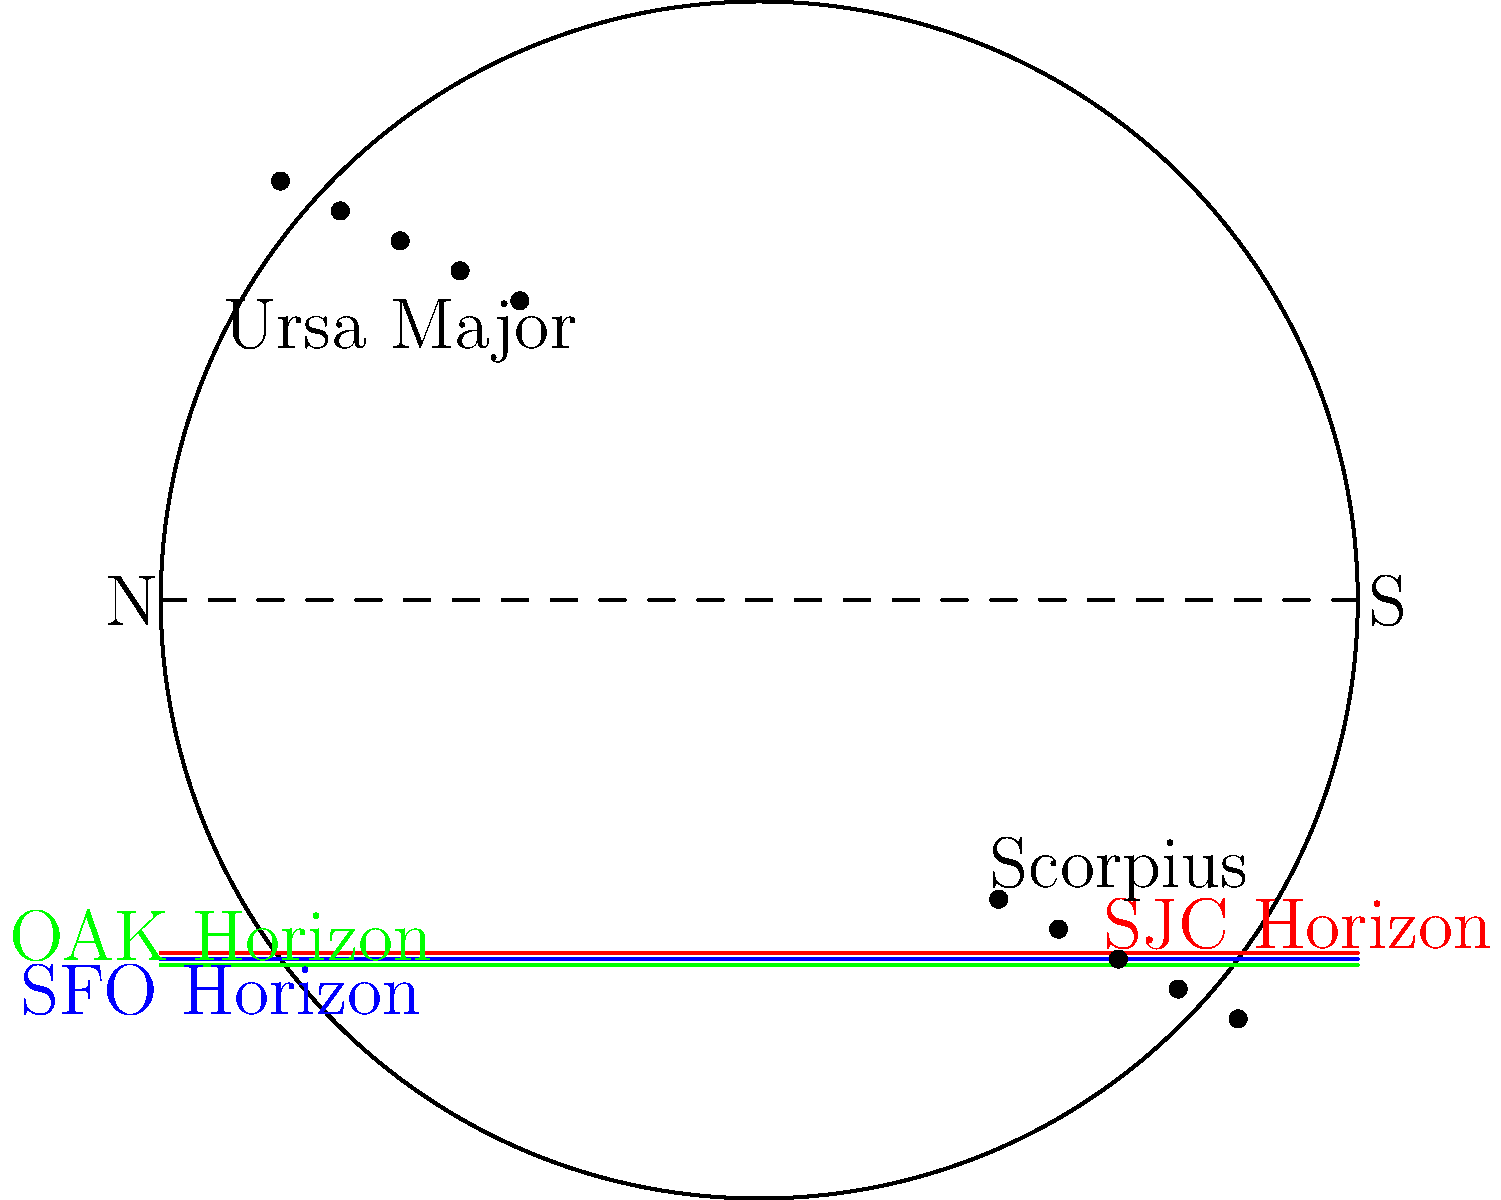Consider three major airports in the San Francisco Bay Area: San Francisco International (SFO), Oakland International (OAK), and San Jose International (SJC). Given their similar latitudes (SFO: 37.6° N, OAK: 37.7° N, SJC: 37.4° N), how would the visibility of the constellations Scorpius and Ursa Major differ when observed from these airports? To answer this question, let's consider the following steps:

1. Latitude effect: The latitude of an observer determines which constellations are visible and for how long.

2. Minimal latitude difference: The three airports are within 0.3° latitude of each other, which is a negligible difference for naked-eye observations.

3. Scorpius visibility:
   - Scorpius is a southern constellation.
   - At the latitude of these airports (approximately 37.5° N), Scorpius will be visible low in the southern sky during summer nights.
   - The slight latitude differences between the airports won't cause a noticeable change in Scorpius's visibility.

4. Ursa Major visibility:
   - Ursa Major is a northern circumpolar constellation for observers at these latitudes.
   - It will be visible year-round from all three airports, circling the north celestial pole.
   - The minimal latitude differences won't affect its circumpolar status or overall visibility.

5. Time of visibility:
   - The time Scorpius spends above the horizon will be slightly longer at SJC (more southern) compared to OAK (more northern), but the difference would be minimal (less than a minute).
   - Ursa Major will be visible for the same amount of time from all three airports, as it never sets at these latitudes.

6. Conclusion: Due to the minimal latitude differences between SFO, OAK, and SJC, there will be no significant difference in the visibility of Scorpius and Ursa Major when observed from these airports.
Answer: No significant difference in visibility 